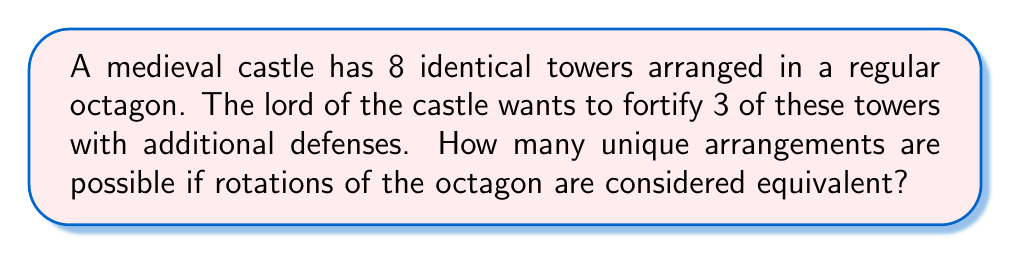What is the answer to this math problem? To solve this problem, we'll use Burnside's lemma from group theory. Let's break it down step-by-step:

1) The group acting on our set is the rotational symmetry group of an octagon, which has order 8.

2) We need to count the number of colorings fixed by each rotation. Let's denote a rotation by $r_k$ where $k$ is the number of steps rotated clockwise.

3) For $r_0$ (identity), all $\binom{8}{3} = 56$ colorings are fixed.

4) For $r_1$, $r_3$, $r_5$, and $r_7$, no non-trivial coloring is fixed.

5) For $r_2$ and $r_6$, colorings with 0, 1, or 2 towers fortified in each half of the octagon are fixed. This gives $1 + \binom{4}{1} + \binom{4}{2} = 8$ fixed colorings.

6) For $r_4$, colorings with 0, 1, 2, or 3 towers fortified in each half of the octagon are fixed. This gives $\binom{4}{0} + \binom{4}{1} + \binom{4}{2} + \binom{4}{3} = 8$ fixed colorings.

7) Applying Burnside's lemma:

   $$\text{Number of orbits} = \frac{1}{|G|} \sum_{g \in G} |X^g|$$

   Where $|G|$ is the order of the group (8 in this case), and $|X^g|$ is the number of colorings fixed by each group element.

8) Substituting our values:

   $$\text{Number of orbits} = \frac{1}{8}(56 + 0 + 8 + 0 + 8 + 0 + 8 + 0) = \frac{80}{8} = 10$$

Therefore, there are 10 unique arrangements.
Answer: 10 unique arrangements 